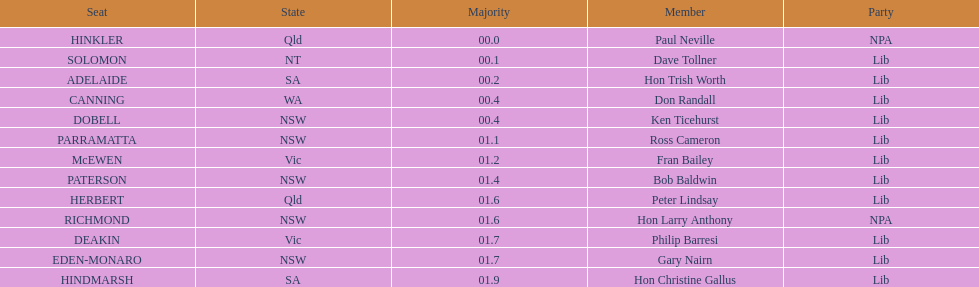Was fran bailey from vic or wa? Vic. 